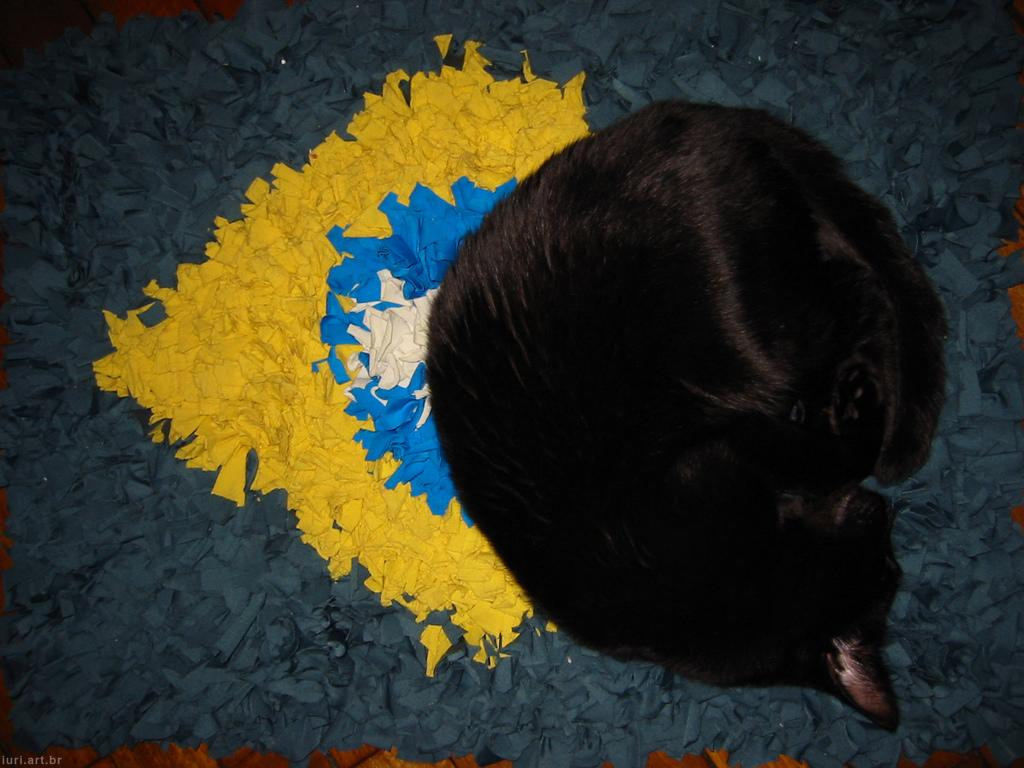What animal can be seen in the image? There is a cat in the image. What is the cat doing in the image? The cat is sleeping. Where is the cat located in the image? The cat is on a mat. What type of tank can be seen in the image? There is no tank present in the image; it features a cat sleeping on a mat. How many flies are visible in the image? There are no flies visible in the image. 